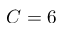Convert formula to latex. <formula><loc_0><loc_0><loc_500><loc_500>C = 6</formula> 